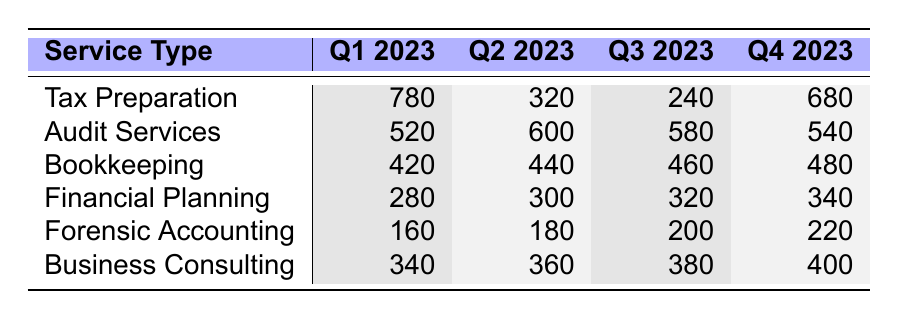What was the total number of billable hours for Tax Preparation in Q1 2023? The table shows that Tax Preparation has 780 billable hours in Q1 2023. Therefore, the total for Tax Preparation in Q1 2023 is 780.
Answer: 780 In which quarter did Audit Services have the highest billable hours? Looking at the table, Audit Services had 600 billable hours in Q2 2023, which is the highest when compared to the other quarters (520, 580, and 540).
Answer: Q2 2023 What is the average number of billable hours for Bookkeeping across all quarters? To find the average, I first sum the billable hours: 420 + 440 + 460 + 480 = 1800. Then, divide by the number of quarters (4): 1800 / 4 = 450.
Answer: 450 Did Forensic Accounting bill more hours in Q4 2023 than in Q2 2023? In the table, Forensic Accounting has 220 billable hours in Q4 2023 and 180 in Q2 2023. Since 220 > 180, the statement is true.
Answer: Yes Which service type saw an increase in billable hours from Q1 to Q4 2023? By comparing the billable hours for each service type from Q1 to Q4 2023, I see that Tax Preparation (780 to 680), Audit Services (520 to 540), Bookkeeping (420 to 480), Financial Planning (280 to 340), Forensic Accounting (160 to 220), and Business Consulting (340 to 400) all increased, notably Bookkeeping, Financial Planning and Forensic Accounting increased.
Answer: Bookkeeping, Financial Planning and Forensic Accounting What is the total billable hours for all service types in Q3 2023? I add together all the billable hours for Q3 2023: 240 (Tax Preparation) + 580 (Audit Services) + 460 (Bookkeeping) + 320 (Financial Planning) + 200 (Forensic Accounting) + 380 (Business Consulting) = 2180.
Answer: 2180 Which service type had the lowest billable hours in any quarter? Looking through the table, Forensic Accounting had the lowest billable hours at 160 in Q1 2023.
Answer: Forensic Accounting (160 in Q1 2023) What was the difference in billable hours between Business Consulting in Q1 and Q4 2023? Business Consulting had 340 billable hours in Q1 and 400 in Q4. The difference is 400 - 340 = 60.
Answer: 60 Is the sum of billable hours for Financial Planning greater than the sum for Forensic Accounting across all quarters? Summing for Financial Planning: 280 + 300 + 320 + 340 = 1240. For Forensic Accounting: 160 + 180 + 200 + 220 = 760. Since 1240 > 760, the answer is yes.
Answer: Yes Which quarter had the highest total billable hours across all service types? I must sum billable hours across each quarter: Q1 = 780 + 520 + 420 + 280 + 160 + 340 = 2500, Q2 = 320 + 600 + 440 + 300 + 180 + 360 = 2200, Q3 = 240 + 580 + 460 + 320 + 200 + 380 = 2180, Q4 = 680 + 540 + 480 + 340 + 220 + 400 = 2660. Q1 has 2500, Q2 has 2200, Q3 has 2180, and Q4 has 2660, so Q4 has the highest total.
Answer: Q4 2023 